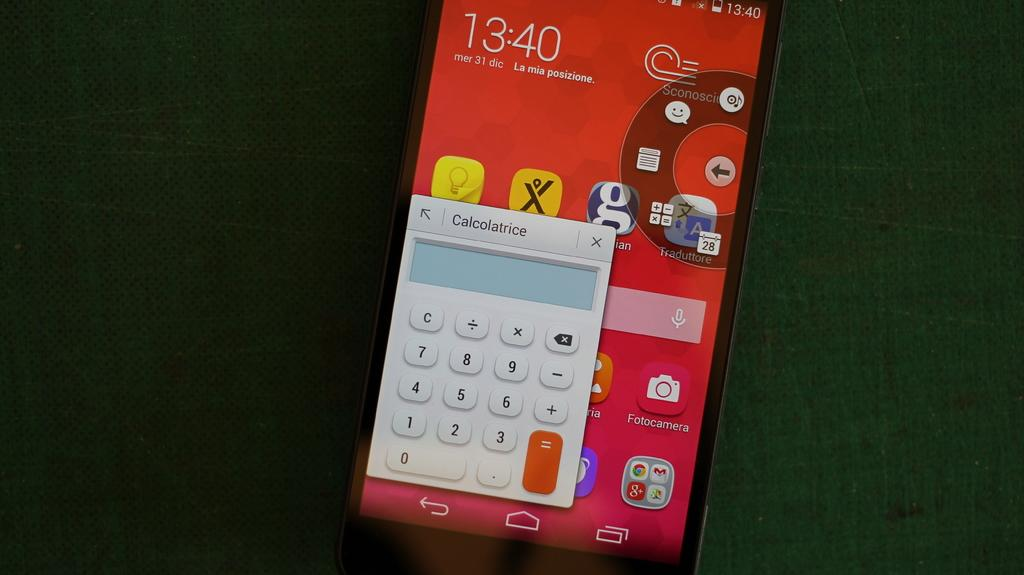Provide a one-sentence caption for the provided image. The calculator is the only app opened on the phone. 